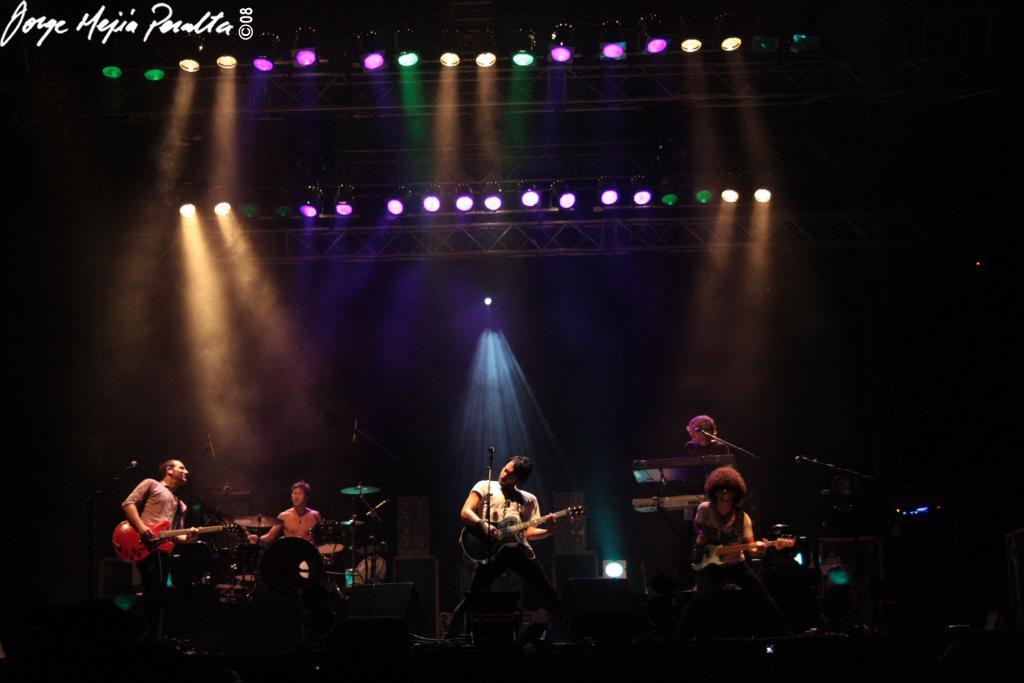How many people are in the image? There are five persons in the image. What are the persons doing in the image? The persons are playing musical instruments. What specific instruments can be seen in the image? The instruments include a guitar, piano, and drums. Is there a person singing in the image? Yes, at least one person is singing on a microphone. What can be seen in the background of the image? There are colorful lights and a pillar in the background. How many trucks can be seen in the image? There are no trucks present in the image. Is there a ring on the finger of any person in the image? There is no ring visible on any person's finger in the image. 